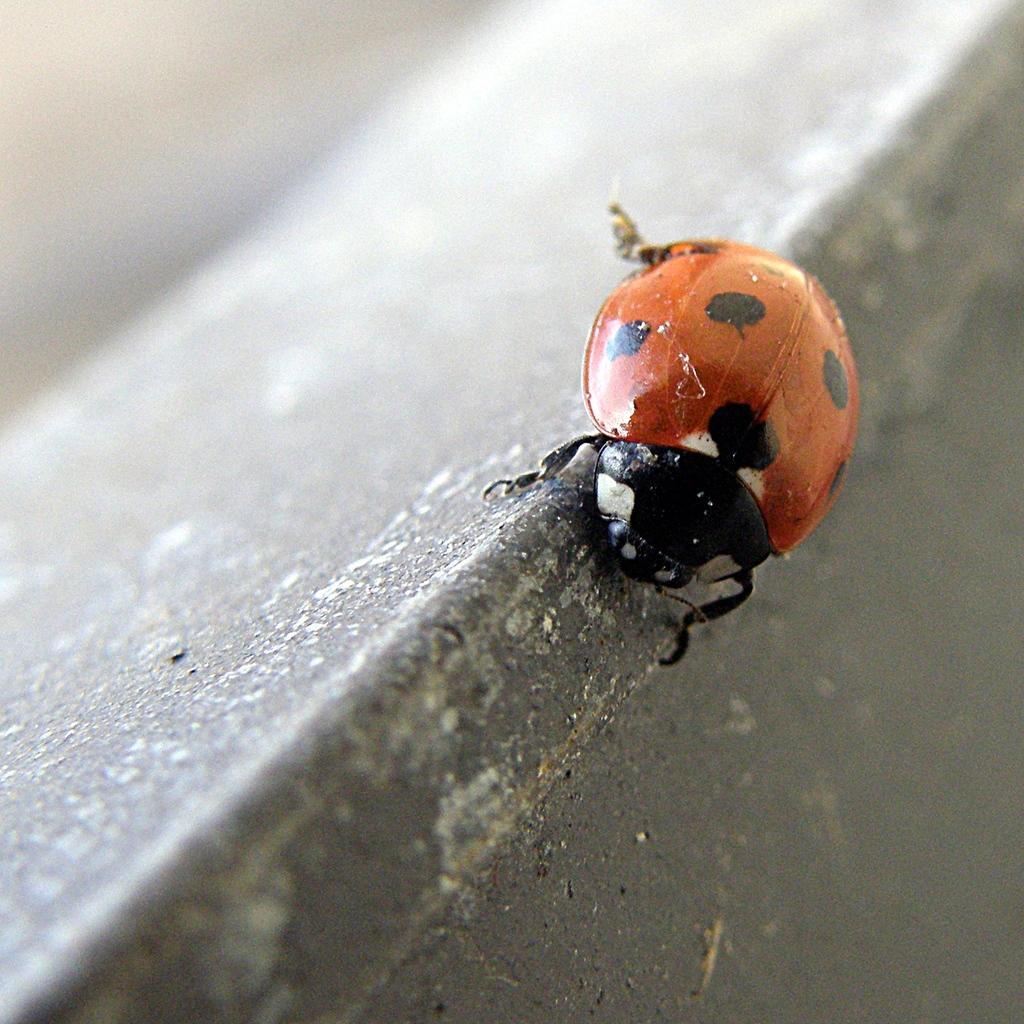Could you give a brief overview of what you see in this image? In this picture we can see a ladybird beetle in the front, there is a blurry background. 